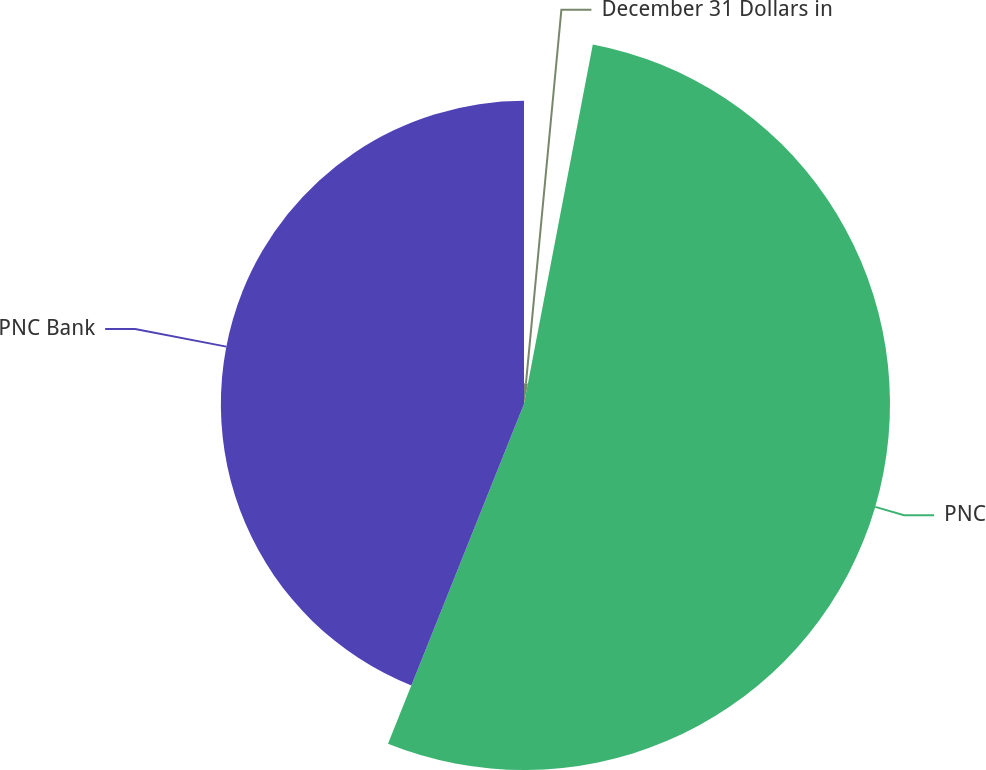Convert chart. <chart><loc_0><loc_0><loc_500><loc_500><pie_chart><fcel>December 31 Dollars in<fcel>PNC<fcel>PNC Bank<nl><fcel>3.01%<fcel>53.05%<fcel>43.94%<nl></chart> 